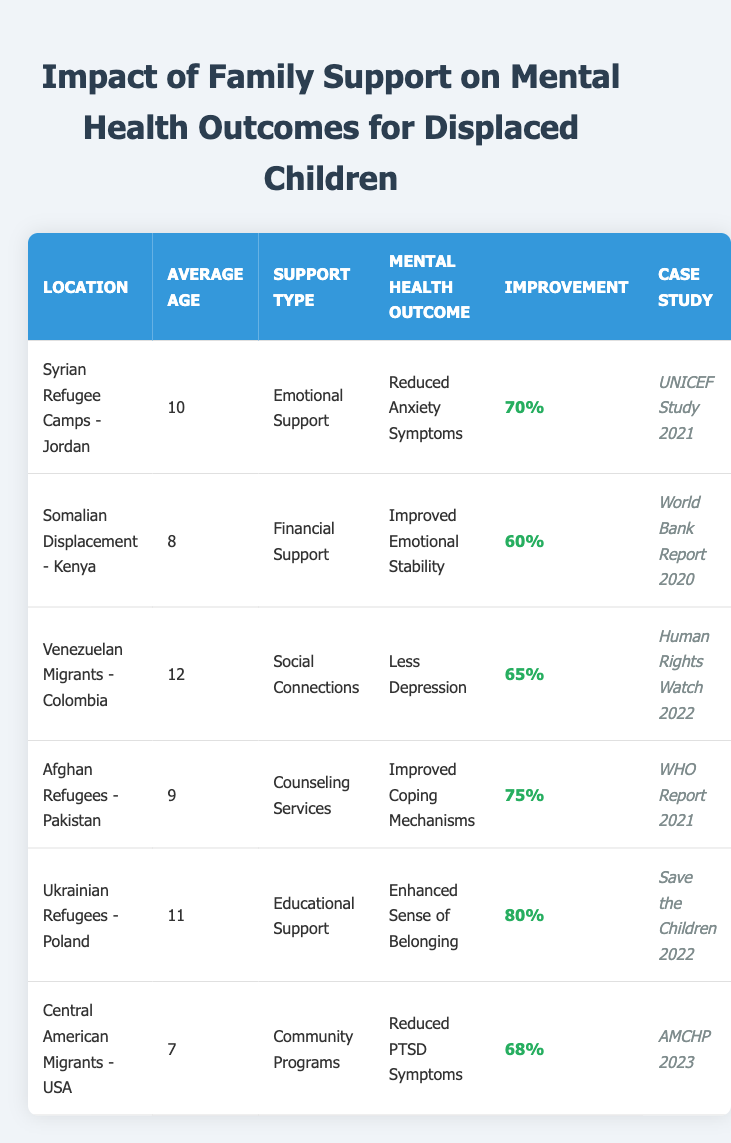What is the mental health outcome for children receiving emotional support in Syrian refugee camps? The table indicates that the mental health outcome for children receiving emotional support in Syrian refugee camps in Jordan is a reduction in anxiety symptoms.
Answer: Reduced Anxiety Symptoms Which case study shows the highest percentage improvement in mental health outcomes? The case study for Ukrainian refugees in Poland shows the highest percentage improvement of 80% related to enhanced sense of belonging through educational support.
Answer: Save the Children 2022 What type of support was provided to Venezuelan migrants in Colombia? The table specifies that Venezuelan migrants in Colombia received social connections as support.
Answer: Social Connections Calculate the average age of children across all the locations listed in the table. The average age is calculated by summing the ages (10 + 8 + 12 + 9 + 11 + 7 = 57) and dividing by the number of entries (6), which gives 57/6 = 9.5.
Answer: 9.5 Is the percentage improvement for counseling services greater than 70%? The table shows that the percentage improvement for counseling services for Afghan refugees in Pakistan is 75%, which is greater than 70%.
Answer: Yes Which mental health outcome has a percentage improvement of 65%? From the table, the mental health outcome associated with a percentage improvement of 65% is "Less Depression" for Venezuelan migrants in Colombia.
Answer: Less Depression How many locations report improved mental health outcomes of 70% or more? By reviewing the table, we find three locations: Afghan refugees in Pakistan (75%), Ukrainian refugees in Poland (80%), and Syrian refugee camps in Jordan (70%), leading to a total of three locations.
Answer: Three locations Is there any support type that leads to reduced PTSD symptoms? The table indicates that community programs provide support leading to a reduction in PTSD symptoms for Central American migrants in the USA.
Answer: Yes What is the only support type that leads to improved emotional stability? According to the table, financial support is the only type leading to improved emotional stability.
Answer: Financial Support Which location has the youngest average age among the groups listed? By analyzing the table, Central American migrants in the USA have the youngest average age of 7 among the listed groups.
Answer: Central American migrants - USA 